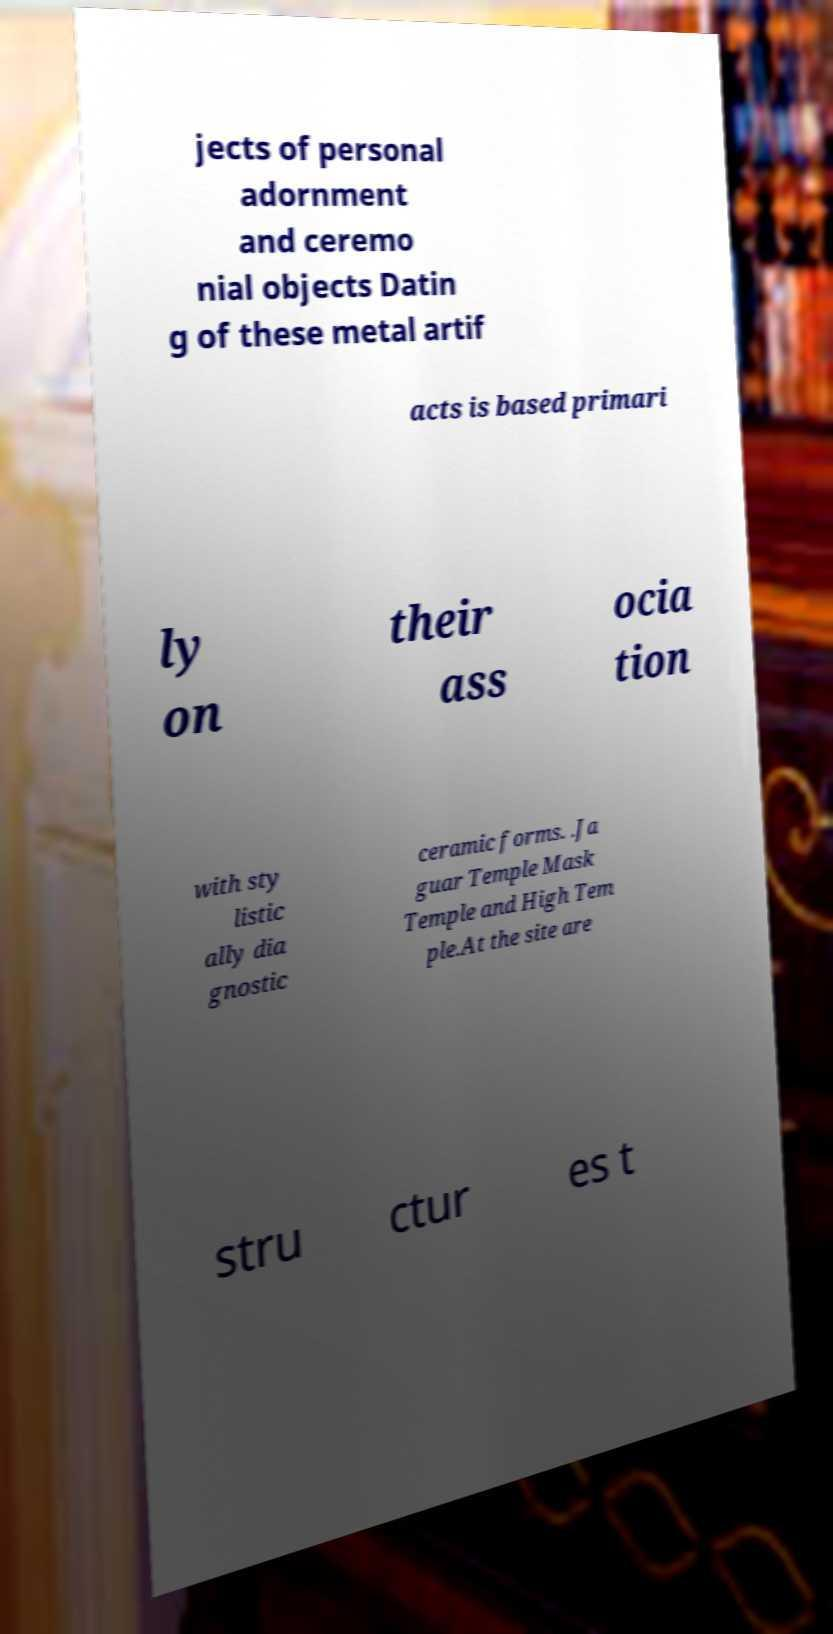Can you accurately transcribe the text from the provided image for me? jects of personal adornment and ceremo nial objects Datin g of these metal artif acts is based primari ly on their ass ocia tion with sty listic ally dia gnostic ceramic forms. .Ja guar Temple Mask Temple and High Tem ple.At the site are stru ctur es t 